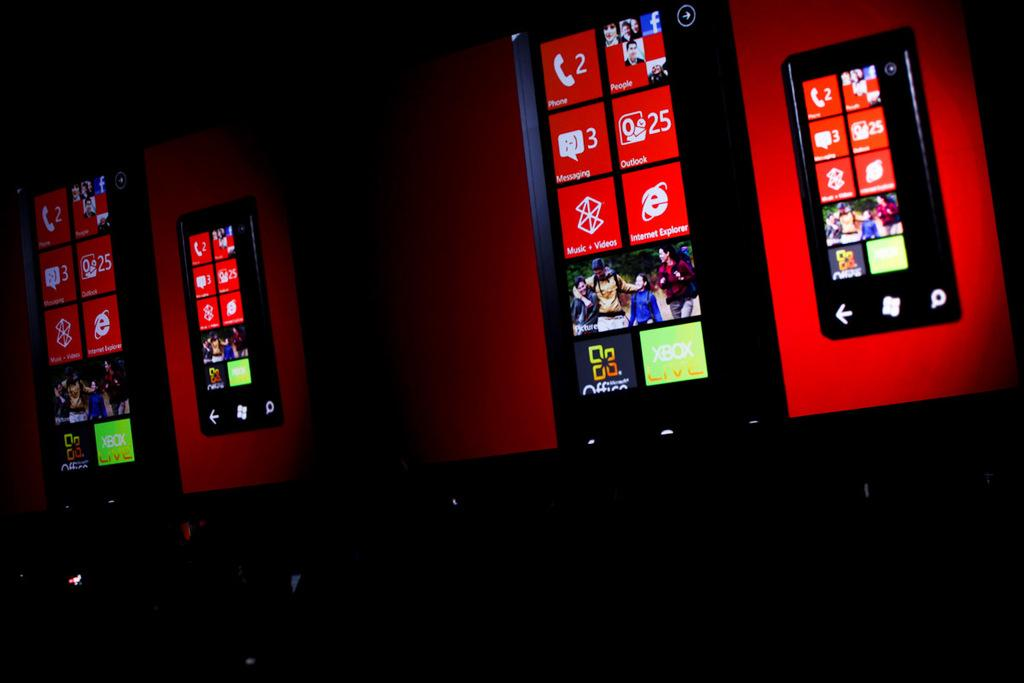<image>
Create a compact narrative representing the image presented. Screens show a phone background that includes a tile with the number 25 on it. 